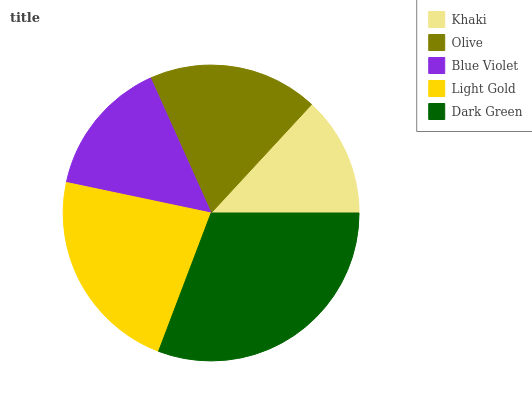Is Khaki the minimum?
Answer yes or no. Yes. Is Dark Green the maximum?
Answer yes or no. Yes. Is Olive the minimum?
Answer yes or no. No. Is Olive the maximum?
Answer yes or no. No. Is Olive greater than Khaki?
Answer yes or no. Yes. Is Khaki less than Olive?
Answer yes or no. Yes. Is Khaki greater than Olive?
Answer yes or no. No. Is Olive less than Khaki?
Answer yes or no. No. Is Olive the high median?
Answer yes or no. Yes. Is Olive the low median?
Answer yes or no. Yes. Is Light Gold the high median?
Answer yes or no. No. Is Light Gold the low median?
Answer yes or no. No. 